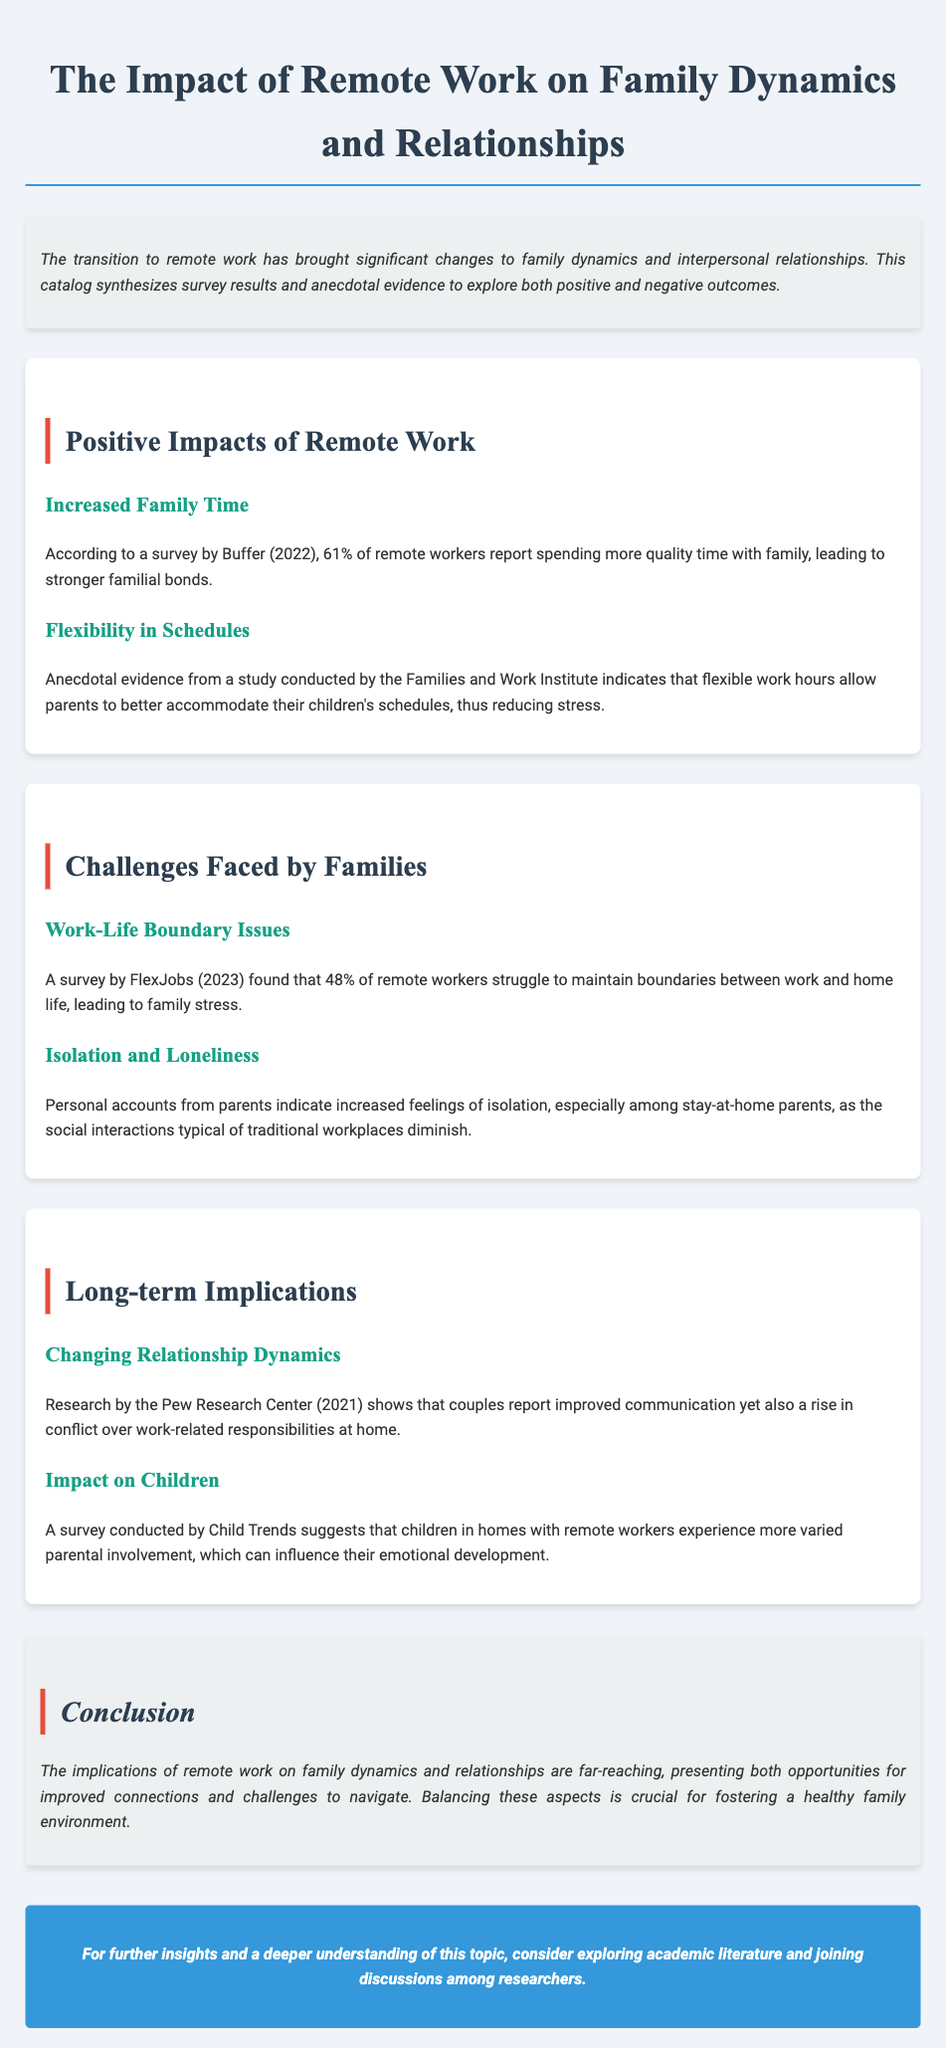What percentage of remote workers report spending more quality time with family? The document states that 61% of remote workers report spending more quality time with family, according to a survey by Buffer (2022).
Answer: 61% What is a challenge faced by remote workers according to FlexJobs (2023)? The document cites that 48% of remote workers struggle to maintain boundaries between work and home life, leading to family stress.
Answer: Work-Life Boundary Issues Which organization conducted a study on changing relationship dynamics? The document mentions research conducted by the Pew Research Center (2021) regarding changing relationship dynamics.
Answer: Pew Research Center What do personal accounts from parents indicate about social interactions? The document notes that personal accounts indicate increased feelings of isolation among stay-at-home parents due to diminished social interactions typical of traditional workplaces.
Answer: Isolation What is the impact on children in homes with remote workers? A survey by Child Trends suggests that children in such homes experience varied parental involvement, influencing their emotional development.
Answer: Varied parental involvement 